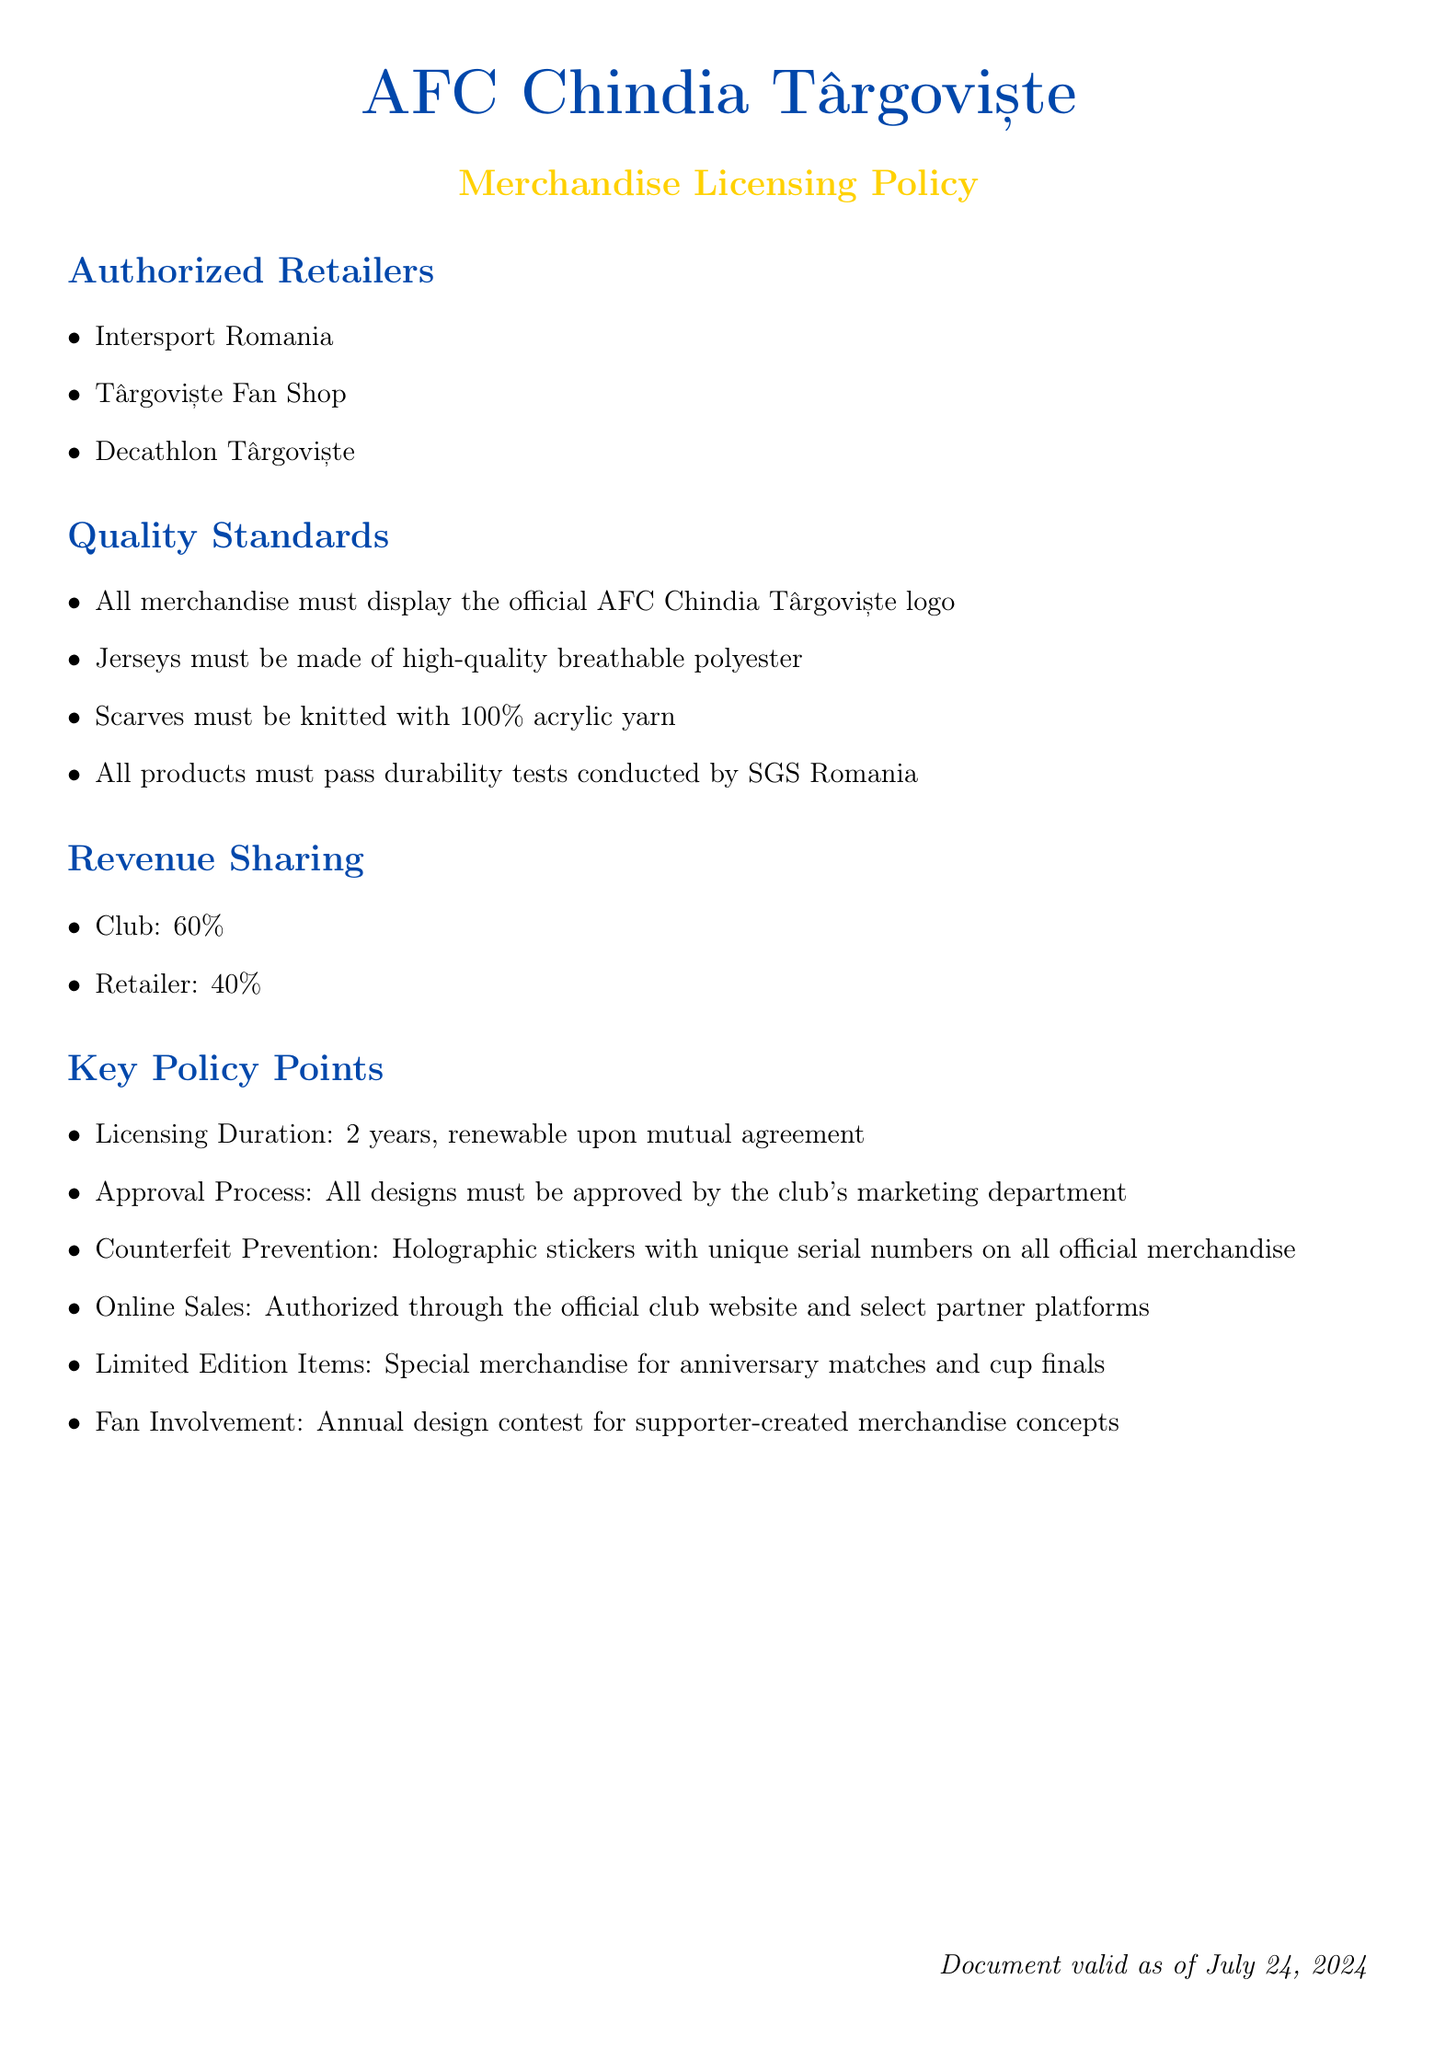What are the authorized retailers? The document lists specific retailers authorized to sell AFC Chindia Târgoviște merchandise.
Answer: Intersport Romania, Târgoviște Fan Shop, Decathlon Târgoviște What percentage of revenue does the club receive? The document specifies the revenue sharing percentage between the club and the retailers.
Answer: 60% What is the required material for jerseys? The document outlines quality standards for merchandise, specifically mentioning materials for jerseys.
Answer: High-quality breathable polyester Which company conducts durability tests? The document mentions which organization is responsible for testing the quality and durability of the merchandise.
Answer: SGS Romania What is the licensing duration? The document specifies the time period for which merchandise licenses are valid and renewable.
Answer: 2 years What is the retailer's revenue share? The document provides a breakdown of revenue percentages allocated to the retailer.
Answer: 40% What type of yarn must scarves use? The document specifies the material that must be used for scarves offered as merchandise.
Answer: 100% acrylic yarn What does the document say about online sales? The document addresses the policies regarding the sale of merchandise through online platforms.
Answer: Authorized through the official club website and select partner platforms What is required for counterfeit prevention? The document includes measures to prevent counterfeiting of merchandise.
Answer: Holographic stickers with unique serial numbers 